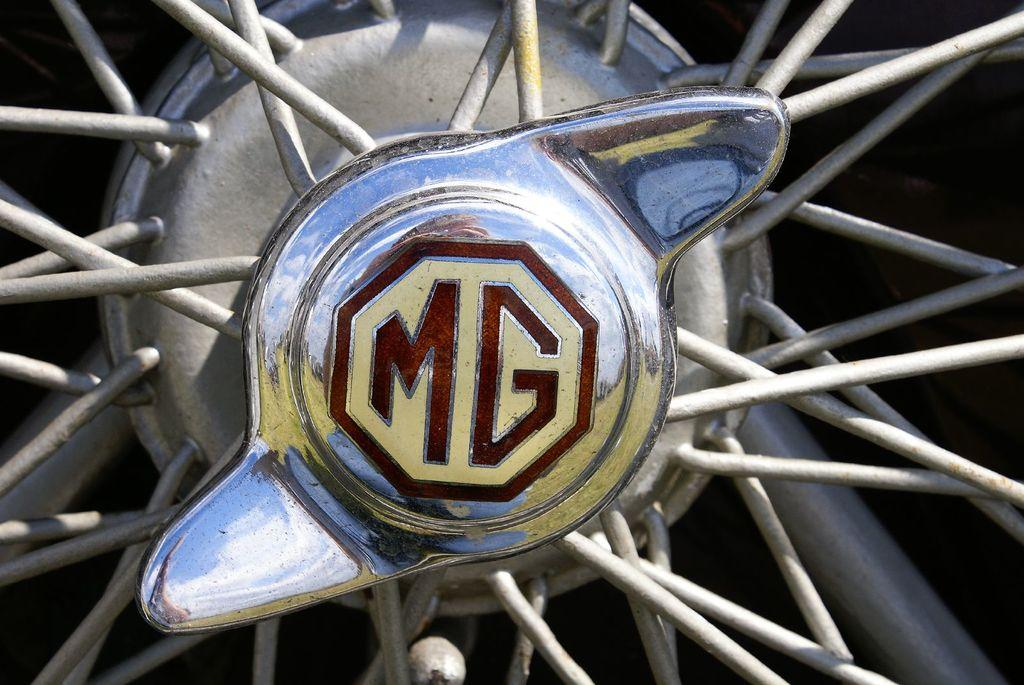What is the main subject of the image? The main subject of the image is a wheel. What can be seen written on the wheel? The wheel has "MG" written on it. How many cows are visible on the page in the image? There are no cows or pages present in the image; it only features a wheel with "MG" written on it. 